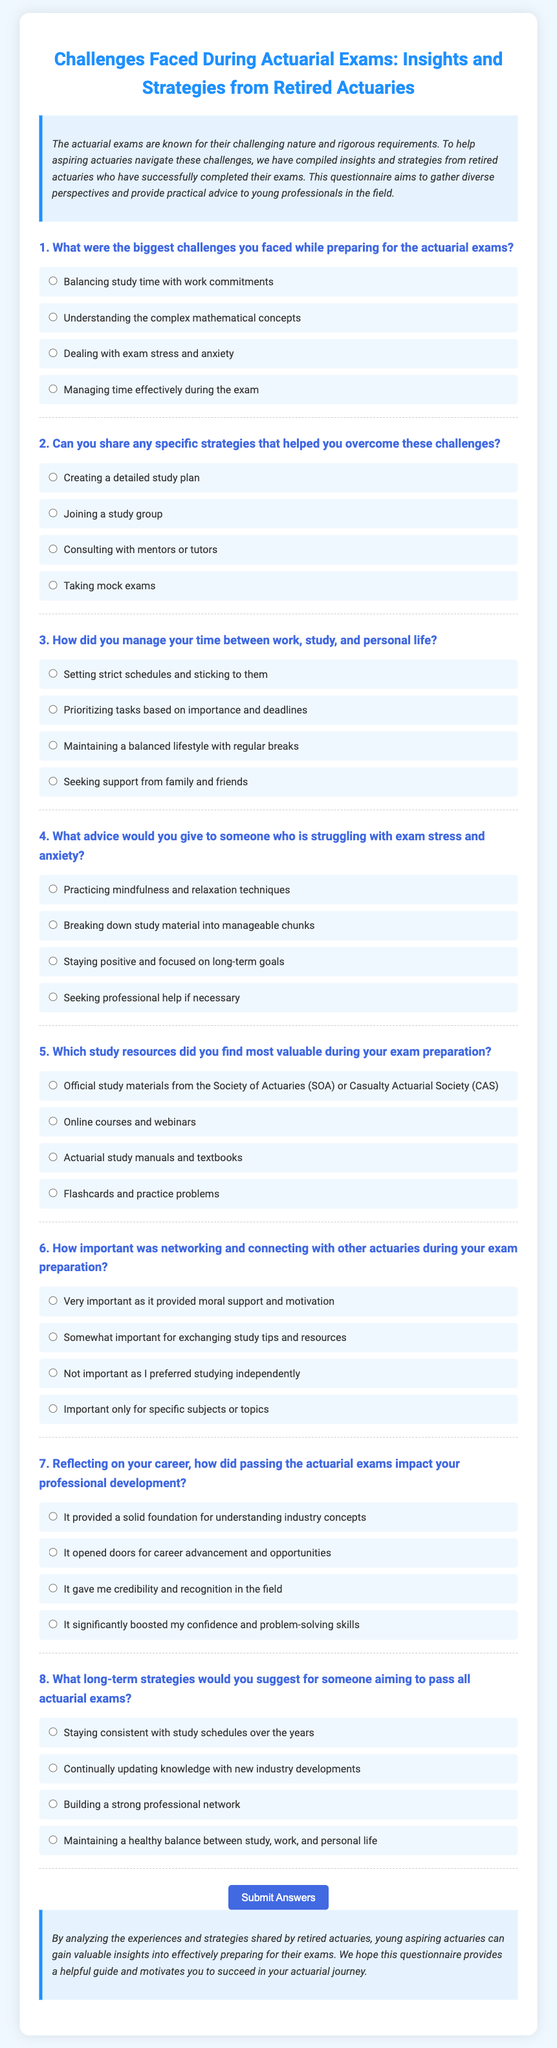What are the main themes of the questionnaire? The questionnaire compiles insights and strategies from retired actuaries to help aspiring actuaries navigate challenges during exam preparations.
Answer: Insights and strategies How many questions are in the questionnaire? The document contains eight distinct questions aimed at gathering information from retired actuaries regarding their experiences and advice on actuarial exams.
Answer: Eight Which organization’s study materials are mentioned as valuable resources? The questionnaire specifies official study materials from the Society of Actuaries (SOA) or Casualty Actuarial Society (CAS) as valuable study resources during exam preparation.
Answer: Society of Actuaries (SOA) or Casualty Actuarial Society (CAS) What face-to-face support is encouraged during the study process? The document highlights the importance of networking and connecting with other actuaries, providing moral support and motivation during exam preparations.
Answer: Networking and connecting What long-term strategy is suggested for passing all actuarial exams? The questionnaire suggests staying consistent with study schedules over the years as a long-term approach to successfully passing all actuarial exams.
Answer: Staying consistent with study schedules How does passing the actuarial exams impact professional development, according to the questionnaire? According to the document, passing the actuarial exams provides a solid foundation for understanding industry concepts, as well as opens doors for career advancement and opportunities.
Answer: Solid foundation What percentage of the respondents agree that practical strategies are beneficial? The document does not specify a percentage of respondents that agree on practical strategies being beneficial.
Answer: Not specified What can aspiring actuaries learn from the questionnaire? The questionnaire aims to provide valuable insights and advice based on the shared experiences and strategies of retired actuaries to help guide aspiring professionals.
Answer: Valuable insights and advice 